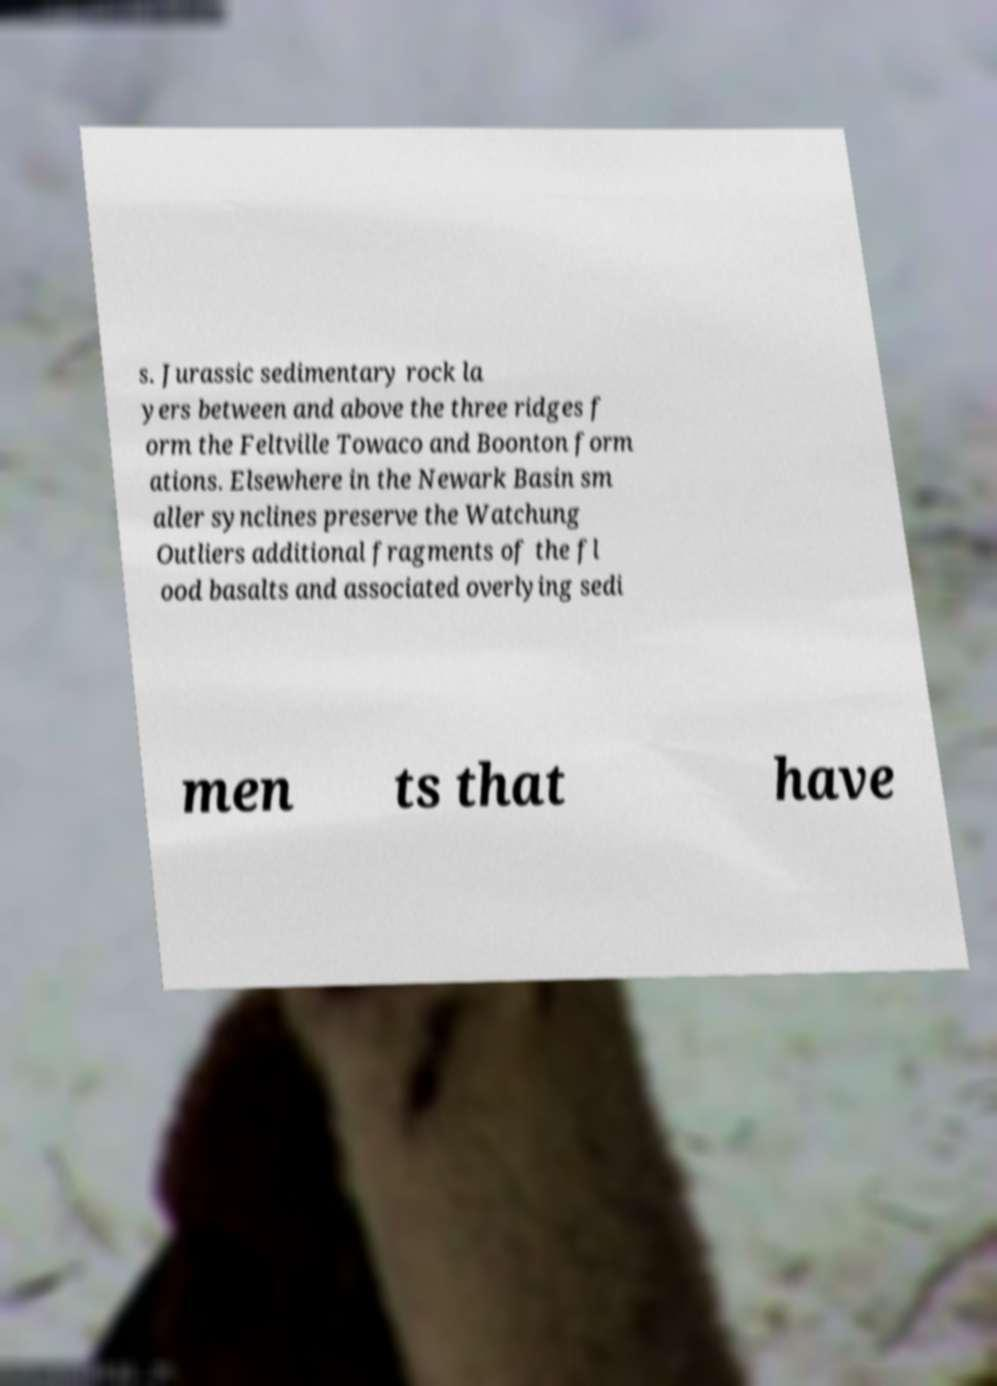Can you read and provide the text displayed in the image?This photo seems to have some interesting text. Can you extract and type it out for me? s. Jurassic sedimentary rock la yers between and above the three ridges f orm the Feltville Towaco and Boonton form ations. Elsewhere in the Newark Basin sm aller synclines preserve the Watchung Outliers additional fragments of the fl ood basalts and associated overlying sedi men ts that have 